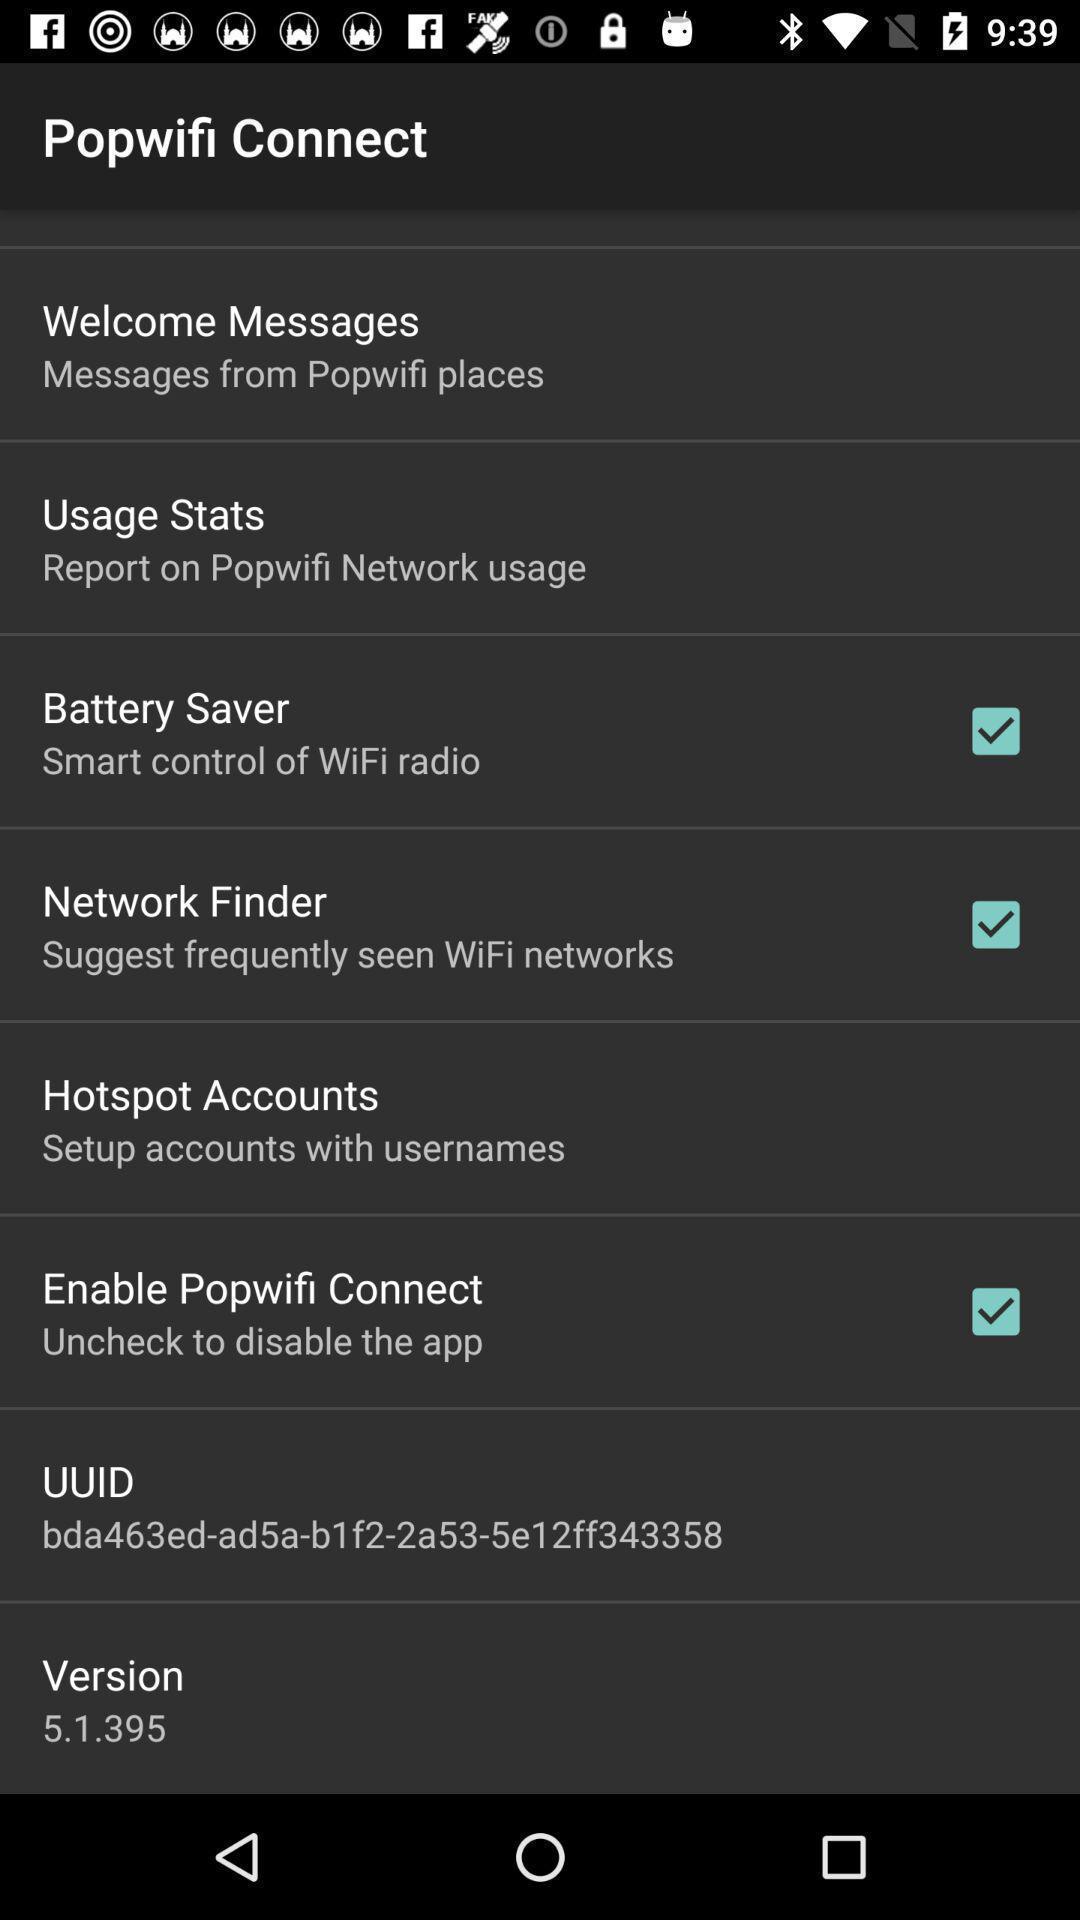Provide a detailed account of this screenshot. Page displaying the list of options for wifi connect settings. 